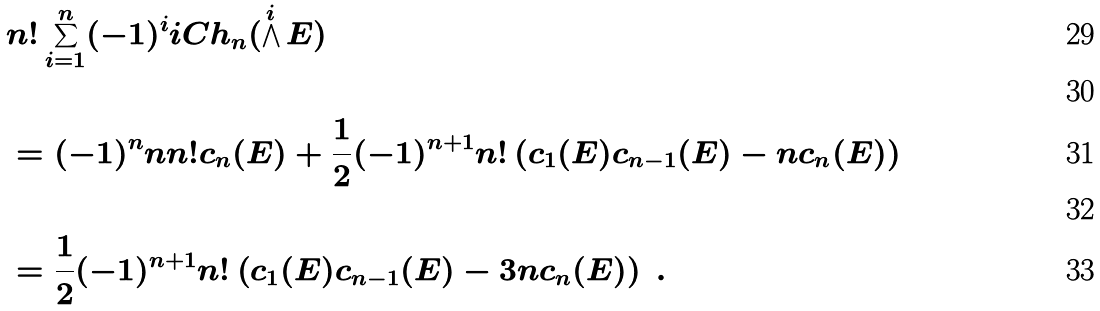Convert formula to latex. <formula><loc_0><loc_0><loc_500><loc_500>& n ! \sum _ { i = 1 } ^ { n } ( - 1 ) ^ { i } i C h _ { n } ( \bigwedge ^ { i } E ) \\ \ \\ & = ( - 1 ) ^ { n } n n ! c _ { n } ( E ) + \frac { 1 } { 2 } ( - 1 ) ^ { n + 1 } n ! \left ( c _ { 1 } ( E ) c _ { n - 1 } ( E ) - n c _ { n } ( E ) \right ) \\ \ \\ & = \frac { 1 } { 2 } ( - 1 ) ^ { n + 1 } n ! \left ( c _ { 1 } ( E ) c _ { n - 1 } ( E ) - 3 n c _ { n } ( E ) \right ) \ .</formula> 